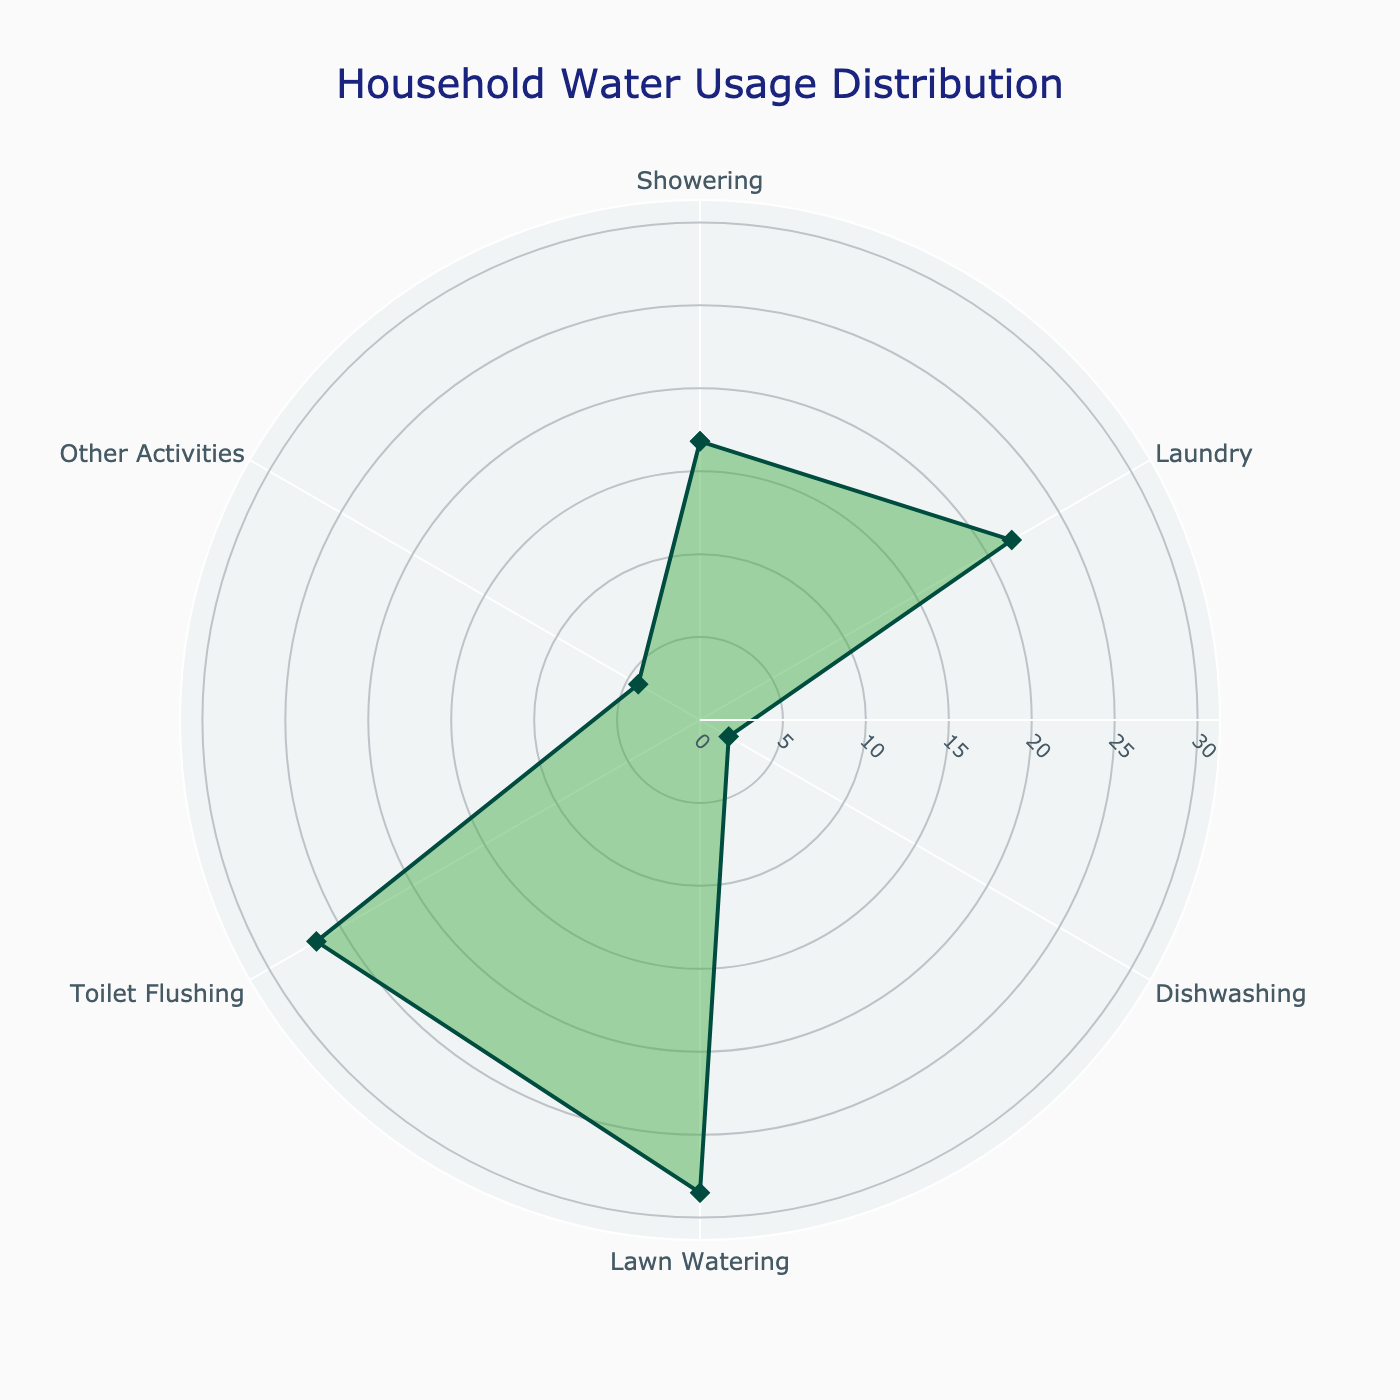How much water percentage is used for toilet flushing? Referring to the figure, find the activity labeled "Toilet Flushing" and note the corresponding percentage value.
Answer: 26.7% Which activity uses the least amount of water? Compare the percentage values for all the activities shown in the figure and identify the one with the smallest value.
Answer: Dishwashing What is the combined percentage of water usage for showering and laundry? Find the percentage values for both "Showering" (16.8%) and "Laundry" (21.7%), then sum these values. 16.8 + 21.7 = 38.5%
Answer: 38.5% Is more water used for lawn watering or toilet flushing? Compare the percentage values for "Lawn Watering" (28.5%) and "Toilet Flushing" (26.7%). Since 28.5 is greater than 26.7, lawn watering uses more water.
Answer: Lawn Watering What activity has the highest water usage, and what is the value? Identify the activity with the highest percentage value in the figure. The highest value is 28.5%, which corresponds to "Lawn Watering."
Answer: Lawn Watering, 28.5% What is the percentage difference between the highest and lowest water-using activities? Identify the highest (Lawn Watering, 28.5%) and lowest (Dishwashing, 2.0%) percentages, then subtract the smaller value from the larger one. 28.5 - 2.0 = 26.5%
Answer: 26.5% How much water percentage is used for activities other than showering? Sum the percentages for all activities except "Showering" (21.7 + 2.0 + 28.5 + 26.7 + 4.3). Then, subtract from 100%. 21.7 + 2.0 + 28.5 + 26.7 + 4.3 = 83.2%. 100 - 83.2 = 83.2%
Answer: 83.2% What is the average percentage usage for the recorded activities? Sum the percentage values for all activities and then divide by the number of activities (6). (16.8 + 21.7 + 2.0 + 28.5 + 26.7 + 4.3) / 6 = 100 / 6 ≈ 16.67%
Answer: ≈16.67% Which two activities combined use almost half of the total household water? To get close to 50%, check combinations of activities. Combination of "Laundry" (21.7%) and "Toilet Flushing" (26.7%) equals 48.4%, which is close to half.
Answer: Laundry and Toilet Flushing 